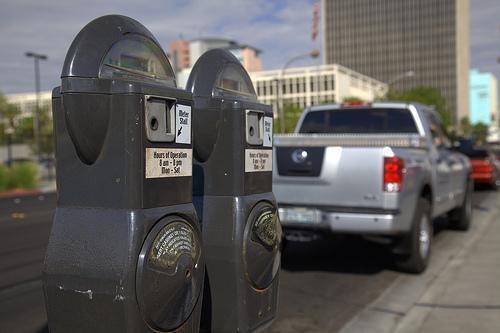How many parking meters are there?
Give a very brief answer. 2. 